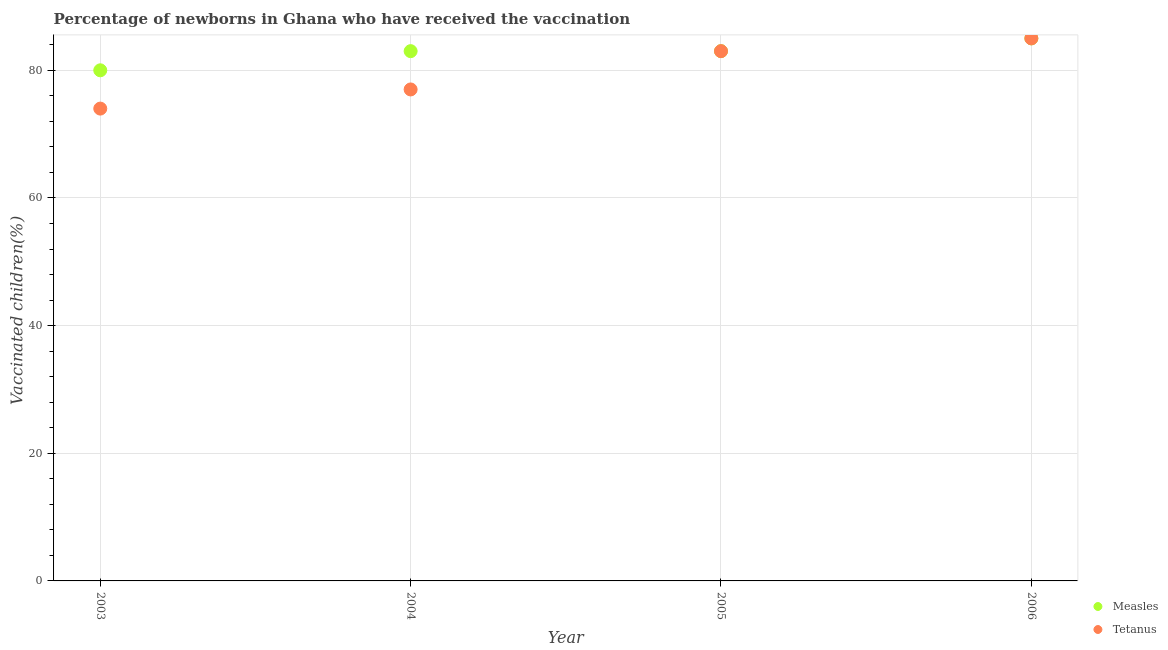Is the number of dotlines equal to the number of legend labels?
Your answer should be very brief. Yes. What is the percentage of newborns who received vaccination for tetanus in 2006?
Your response must be concise. 85. Across all years, what is the maximum percentage of newborns who received vaccination for measles?
Make the answer very short. 85. Across all years, what is the minimum percentage of newborns who received vaccination for measles?
Your answer should be compact. 80. In which year was the percentage of newborns who received vaccination for measles minimum?
Keep it short and to the point. 2003. What is the total percentage of newborns who received vaccination for measles in the graph?
Offer a very short reply. 331. What is the difference between the percentage of newborns who received vaccination for tetanus in 2003 and that in 2004?
Make the answer very short. -3. What is the difference between the percentage of newborns who received vaccination for measles in 2006 and the percentage of newborns who received vaccination for tetanus in 2004?
Make the answer very short. 8. What is the average percentage of newborns who received vaccination for tetanus per year?
Offer a very short reply. 79.75. What is the ratio of the percentage of newborns who received vaccination for tetanus in 2004 to that in 2006?
Ensure brevity in your answer.  0.91. Is the percentage of newborns who received vaccination for measles in 2003 less than that in 2004?
Provide a succinct answer. Yes. Is the difference between the percentage of newborns who received vaccination for measles in 2005 and 2006 greater than the difference between the percentage of newborns who received vaccination for tetanus in 2005 and 2006?
Keep it short and to the point. No. What is the difference between the highest and the lowest percentage of newborns who received vaccination for tetanus?
Give a very brief answer. 11. Is the sum of the percentage of newborns who received vaccination for tetanus in 2005 and 2006 greater than the maximum percentage of newborns who received vaccination for measles across all years?
Offer a terse response. Yes. Is the percentage of newborns who received vaccination for measles strictly greater than the percentage of newborns who received vaccination for tetanus over the years?
Provide a short and direct response. No. How many dotlines are there?
Your answer should be very brief. 2. Does the graph contain any zero values?
Provide a short and direct response. No. Does the graph contain grids?
Make the answer very short. Yes. Where does the legend appear in the graph?
Offer a terse response. Bottom right. What is the title of the graph?
Keep it short and to the point. Percentage of newborns in Ghana who have received the vaccination. What is the label or title of the X-axis?
Keep it short and to the point. Year. What is the label or title of the Y-axis?
Provide a succinct answer. Vaccinated children(%)
. What is the Vaccinated children(%)
 of Tetanus in 2003?
Your answer should be very brief. 74. What is the Vaccinated children(%)
 in Measles in 2004?
Give a very brief answer. 83. What is the Vaccinated children(%)
 of Tetanus in 2004?
Provide a short and direct response. 77. What is the Vaccinated children(%)
 of Measles in 2005?
Keep it short and to the point. 83. What is the Vaccinated children(%)
 in Tetanus in 2006?
Your response must be concise. 85. Across all years, what is the maximum Vaccinated children(%)
 in Measles?
Provide a short and direct response. 85. Across all years, what is the minimum Vaccinated children(%)
 of Tetanus?
Your answer should be very brief. 74. What is the total Vaccinated children(%)
 in Measles in the graph?
Keep it short and to the point. 331. What is the total Vaccinated children(%)
 in Tetanus in the graph?
Keep it short and to the point. 319. What is the difference between the Vaccinated children(%)
 in Measles in 2003 and that in 2004?
Provide a short and direct response. -3. What is the difference between the Vaccinated children(%)
 in Tetanus in 2003 and that in 2004?
Make the answer very short. -3. What is the difference between the Vaccinated children(%)
 of Measles in 2003 and that in 2005?
Make the answer very short. -3. What is the difference between the Vaccinated children(%)
 of Tetanus in 2003 and that in 2005?
Provide a succinct answer. -9. What is the difference between the Vaccinated children(%)
 of Measles in 2003 and that in 2006?
Your answer should be very brief. -5. What is the difference between the Vaccinated children(%)
 in Tetanus in 2003 and that in 2006?
Offer a very short reply. -11. What is the difference between the Vaccinated children(%)
 of Measles in 2004 and that in 2005?
Your answer should be very brief. 0. What is the difference between the Vaccinated children(%)
 in Measles in 2004 and that in 2006?
Offer a very short reply. -2. What is the difference between the Vaccinated children(%)
 in Tetanus in 2005 and that in 2006?
Ensure brevity in your answer.  -2. What is the difference between the Vaccinated children(%)
 in Measles in 2004 and the Vaccinated children(%)
 in Tetanus in 2005?
Ensure brevity in your answer.  0. What is the difference between the Vaccinated children(%)
 of Measles in 2004 and the Vaccinated children(%)
 of Tetanus in 2006?
Provide a short and direct response. -2. What is the average Vaccinated children(%)
 of Measles per year?
Offer a terse response. 82.75. What is the average Vaccinated children(%)
 of Tetanus per year?
Offer a terse response. 79.75. In the year 2005, what is the difference between the Vaccinated children(%)
 of Measles and Vaccinated children(%)
 of Tetanus?
Give a very brief answer. 0. What is the ratio of the Vaccinated children(%)
 in Measles in 2003 to that in 2004?
Your answer should be very brief. 0.96. What is the ratio of the Vaccinated children(%)
 in Tetanus in 2003 to that in 2004?
Your answer should be compact. 0.96. What is the ratio of the Vaccinated children(%)
 in Measles in 2003 to that in 2005?
Keep it short and to the point. 0.96. What is the ratio of the Vaccinated children(%)
 of Tetanus in 2003 to that in 2005?
Offer a terse response. 0.89. What is the ratio of the Vaccinated children(%)
 in Measles in 2003 to that in 2006?
Your answer should be compact. 0.94. What is the ratio of the Vaccinated children(%)
 of Tetanus in 2003 to that in 2006?
Ensure brevity in your answer.  0.87. What is the ratio of the Vaccinated children(%)
 of Tetanus in 2004 to that in 2005?
Your response must be concise. 0.93. What is the ratio of the Vaccinated children(%)
 in Measles in 2004 to that in 2006?
Keep it short and to the point. 0.98. What is the ratio of the Vaccinated children(%)
 in Tetanus in 2004 to that in 2006?
Offer a terse response. 0.91. What is the ratio of the Vaccinated children(%)
 of Measles in 2005 to that in 2006?
Give a very brief answer. 0.98. What is the ratio of the Vaccinated children(%)
 in Tetanus in 2005 to that in 2006?
Your response must be concise. 0.98. What is the difference between the highest and the second highest Vaccinated children(%)
 of Tetanus?
Make the answer very short. 2. What is the difference between the highest and the lowest Vaccinated children(%)
 in Measles?
Your answer should be compact. 5. What is the difference between the highest and the lowest Vaccinated children(%)
 of Tetanus?
Give a very brief answer. 11. 